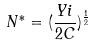<formula> <loc_0><loc_0><loc_500><loc_500>N ^ { * } = ( \frac { Y i } { 2 C } ) ^ { \frac { 1 } { 2 } }</formula> 